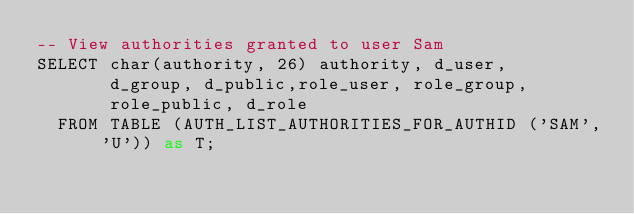<code> <loc_0><loc_0><loc_500><loc_500><_SQL_>-- View authorities granted to user Sam 
SELECT char(authority, 26) authority, d_user, 
       d_group, d_public,role_user, role_group, 
       role_public, d_role 
  FROM TABLE (AUTH_LIST_AUTHORITIES_FOR_AUTHID ('SAM', 'U')) as T;





</code> 